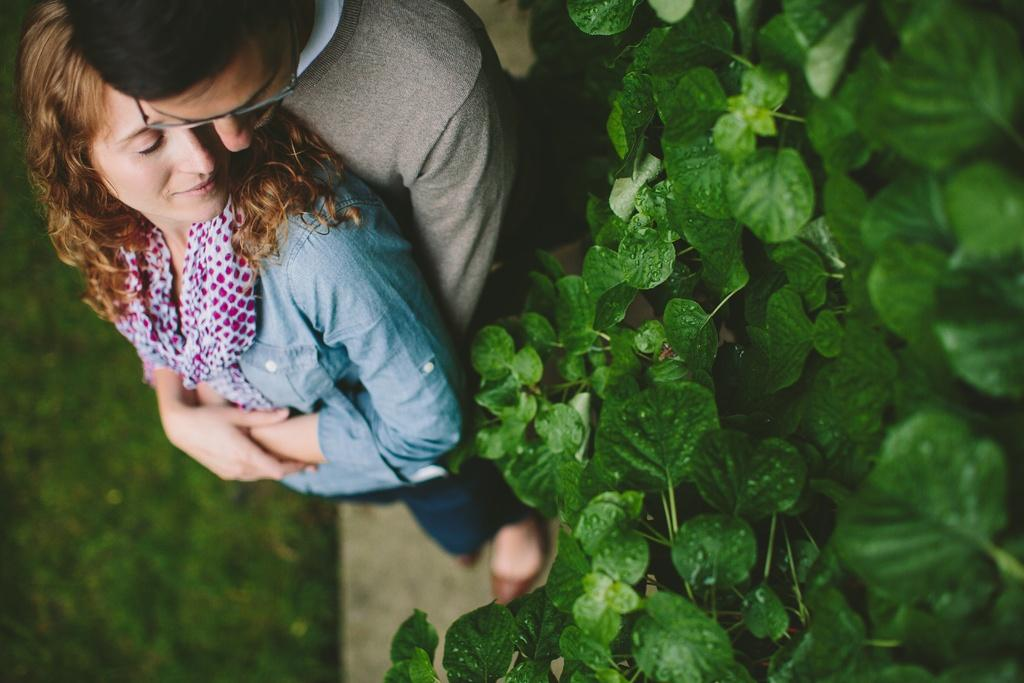How many people are in the image? There are two people standing in the image. What type of vegetation is visible in the image? Green leaves and grass are present in the image. What type of drawer can be seen in the image? There is no drawer present in the image. How is the distribution of resources depicted in the image? The image does not depict any distribution of resources; it features two people and vegetation. 